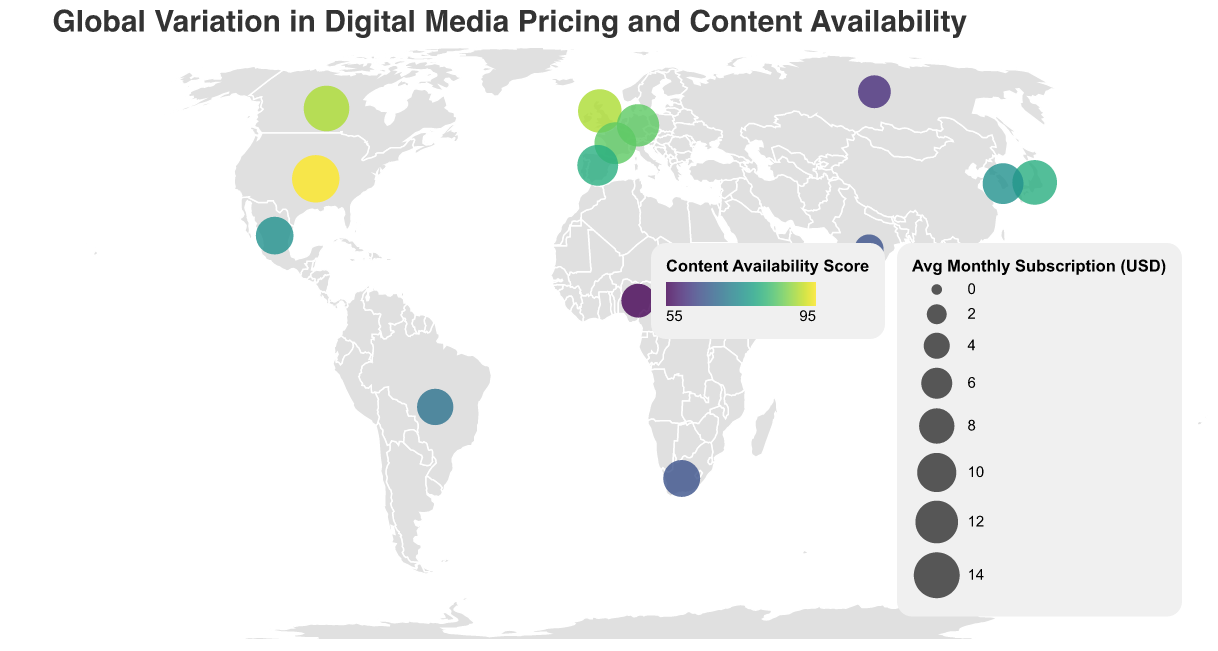Which country has the highest content availability score? By examining the color shade and looking at the tooltip data, we can see that the United States has the highest content availability score.
Answer: United States Which region has the highest average subscription cost? Compare the average subscription costs across regions by looking at the sizes of the circles and using the region information in the tooltip data. North America has the highest average subscription cost.
Answer: North America What is the relationship between content availability score and piracy rate for Nigeria? Check Nigeria's tooltip data to see its content availability score and piracy rate. Nigeria has a content availability score of 55 and a piracy rate of 60%.
Answer: Content availability score is 55, and piracy is 60% Which regions appear to have a higher piracy rate? By looking at the tooltip data for various countries, it becomes evident that Africa has higher piracy rates, especially Nigeria and South Africa.
Answer: Africa Which country in Europe has the lowest average monthly subscription cost? Check the size of the circles and the tooltip information for countries in Europe. Russia has the lowest average monthly subscription cost in Europe.
Answer: Russia Which country has the lowest content availability score and what is its piracy rate? By examining the brightness of the colors and the tooltip data, we find that Nigeria has the lowest content availability score of 55 and a piracy rate of 60%.
Answer: Nigeria; 60% Is there a correlation between average monthly subscription cost and content availability score? Look at the general trend in the circle sizes and color intensities. Countries with higher subscription costs also tend to have higher content availability scores.
Answer: Positive correlation Which country in Asia has the highest piracy rate? By examining the tooltip data for Asian countries, we can determine that India has the highest piracy rate.
Answer: India Compare the piracy rates of Brazil and Mexico. Which one is higher? Using the tooltip data, we find that Brazil has a piracy rate of 35%, whereas Mexico has a piracy rate of 30%. Brazil has a higher piracy rate.
Answer: Brazil What can you infer about the relationship between subscription cost and piracy rate? By observing the tooltip data, countries with lower subscription costs, like India and Nigeria, tend to have higher piracy rates, suggesting that higher costs might be a barrier that leads to more piracy.
Answer: Lower subscription costs correlate with higher piracy rates 